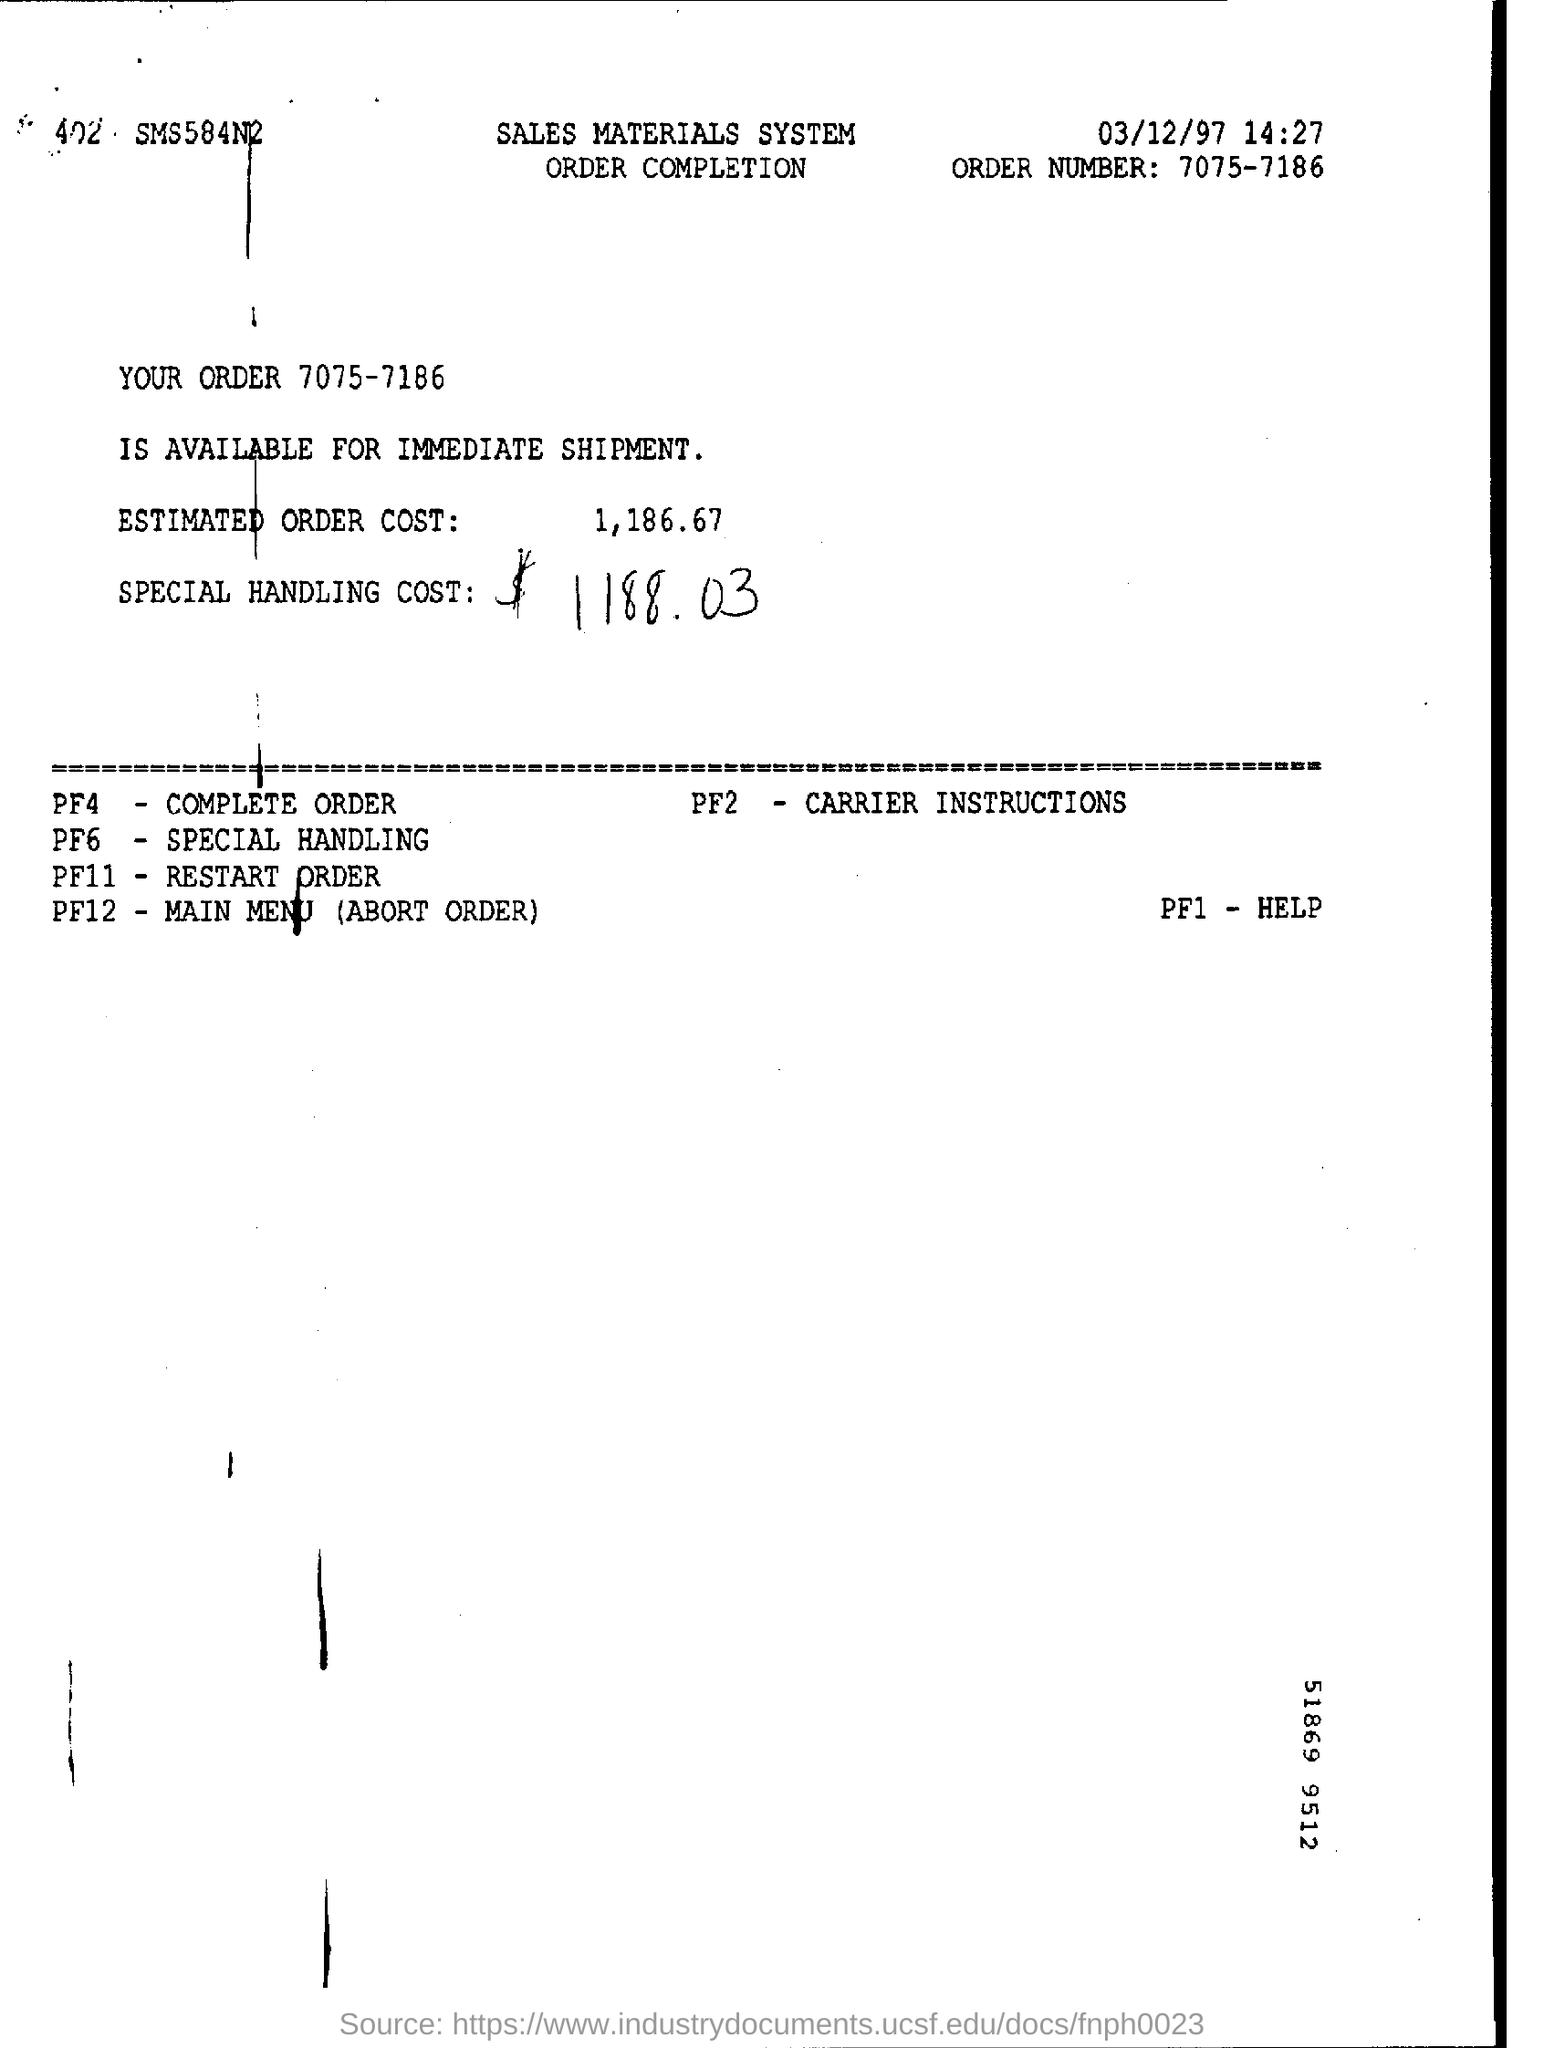Outline some significant characteristics in this image. The title of the document is related to the sales materials system and order completion process. The order number is 7075-7186. What is written in the PF11 Field? It is the restart order. The code for CARRIER INSTRUCTIONS is PF2. 